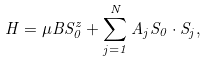Convert formula to latex. <formula><loc_0><loc_0><loc_500><loc_500>H = \mu B S _ { 0 } ^ { z } + \sum _ { j = 1 } ^ { N } A _ { j } S _ { 0 } \cdot S _ { j } ,</formula> 